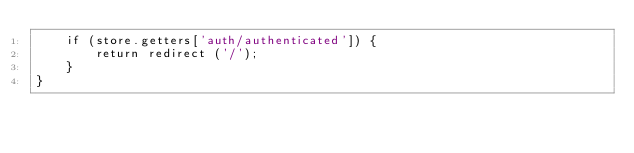Convert code to text. <code><loc_0><loc_0><loc_500><loc_500><_JavaScript_>    if (store.getters['auth/authenticated']) {
        return redirect ('/');
    }
}</code> 